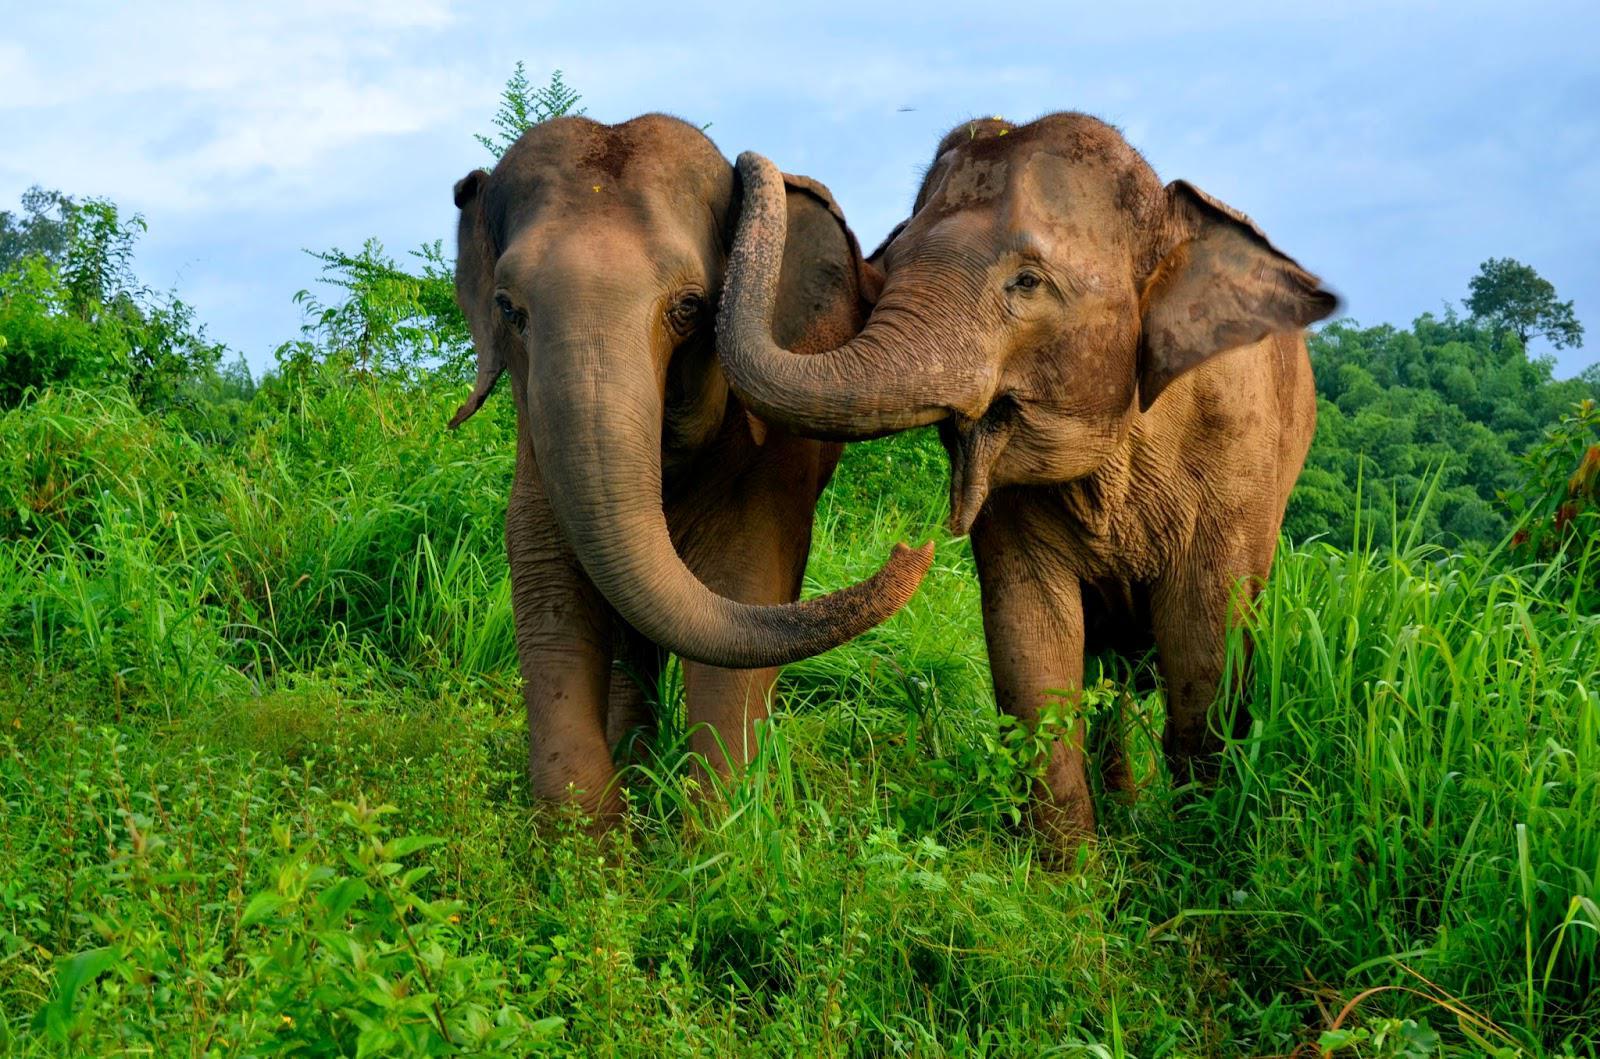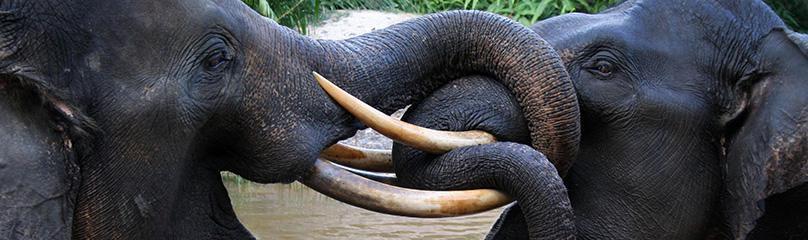The first image is the image on the left, the second image is the image on the right. Given the left and right images, does the statement "The elephants in the image on the right are butting heads." hold true? Answer yes or no. Yes. The first image is the image on the left, the second image is the image on the right. Given the left and right images, does the statement "An image shows two adult elephants next to a baby elephant." hold true? Answer yes or no. No. 